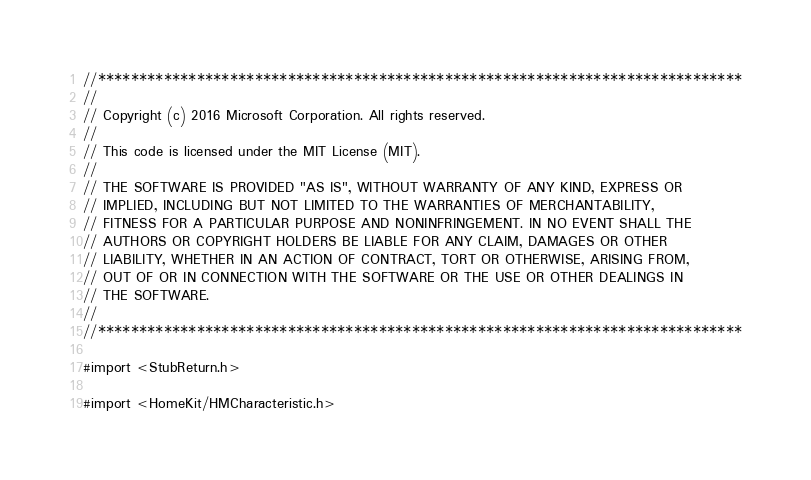Convert code to text. <code><loc_0><loc_0><loc_500><loc_500><_ObjectiveC_>//******************************************************************************
//
// Copyright (c) 2016 Microsoft Corporation. All rights reserved.
//
// This code is licensed under the MIT License (MIT).
//
// THE SOFTWARE IS PROVIDED "AS IS", WITHOUT WARRANTY OF ANY KIND, EXPRESS OR
// IMPLIED, INCLUDING BUT NOT LIMITED TO THE WARRANTIES OF MERCHANTABILITY,
// FITNESS FOR A PARTICULAR PURPOSE AND NONINFRINGEMENT. IN NO EVENT SHALL THE
// AUTHORS OR COPYRIGHT HOLDERS BE LIABLE FOR ANY CLAIM, DAMAGES OR OTHER
// LIABILITY, WHETHER IN AN ACTION OF CONTRACT, TORT OR OTHERWISE, ARISING FROM,
// OUT OF OR IN CONNECTION WITH THE SOFTWARE OR THE USE OR OTHER DEALINGS IN
// THE SOFTWARE.
//
//******************************************************************************

#import <StubReturn.h>

#import <HomeKit/HMCharacteristic.h></code> 